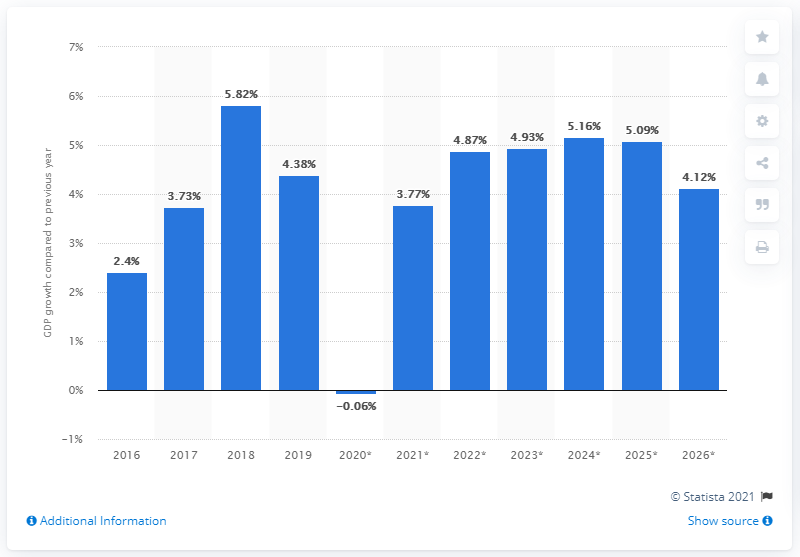Point out several critical features in this image. The Democratic Republic of the Congo's real GDP grew by 4.38% in 2019 compared to the previous year. 